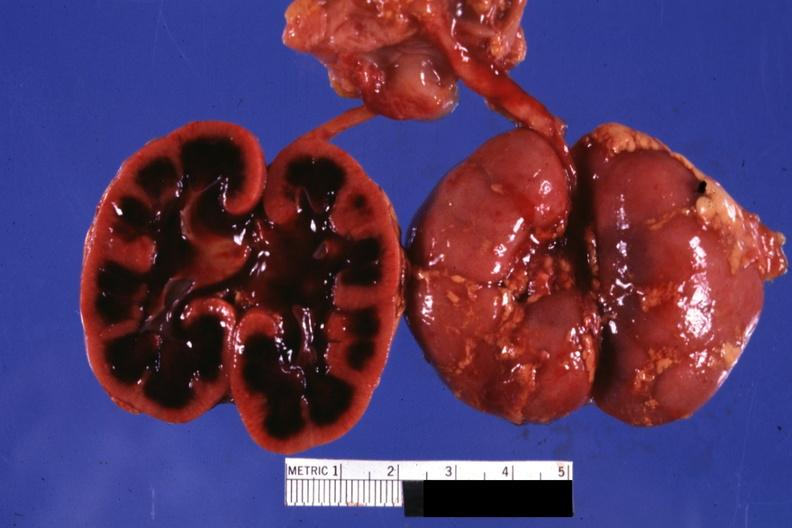what is present?
Answer the question using a single word or phrase. Ischemia infant 